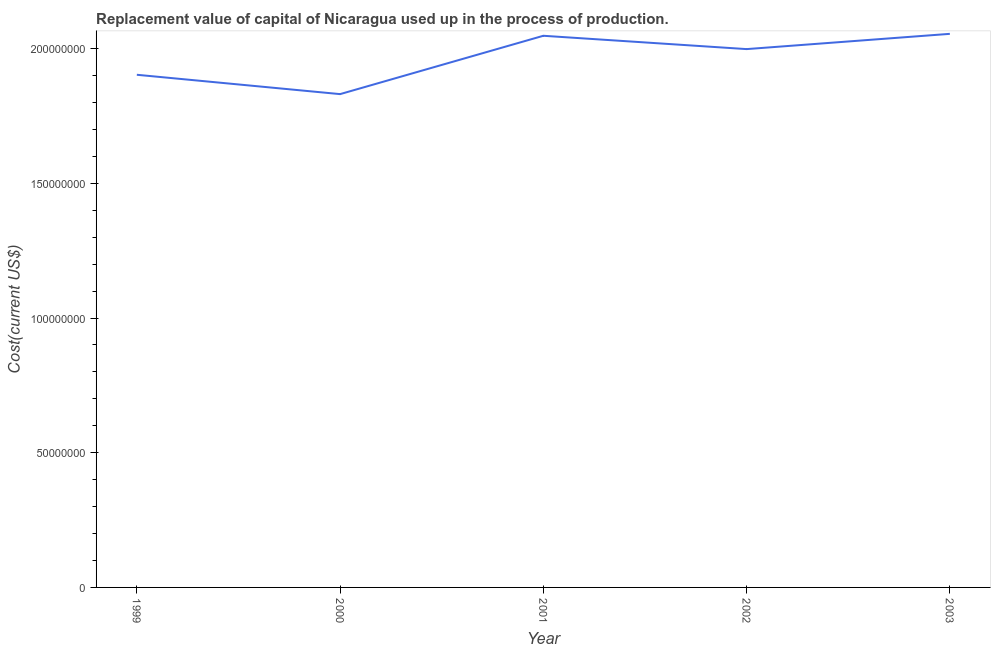What is the consumption of fixed capital in 1999?
Provide a succinct answer. 1.90e+08. Across all years, what is the maximum consumption of fixed capital?
Your answer should be very brief. 2.05e+08. Across all years, what is the minimum consumption of fixed capital?
Keep it short and to the point. 1.83e+08. In which year was the consumption of fixed capital maximum?
Offer a terse response. 2003. In which year was the consumption of fixed capital minimum?
Give a very brief answer. 2000. What is the sum of the consumption of fixed capital?
Provide a succinct answer. 9.83e+08. What is the difference between the consumption of fixed capital in 1999 and 2001?
Keep it short and to the point. -1.45e+07. What is the average consumption of fixed capital per year?
Offer a terse response. 1.97e+08. What is the median consumption of fixed capital?
Keep it short and to the point. 2.00e+08. In how many years, is the consumption of fixed capital greater than 80000000 US$?
Your response must be concise. 5. What is the ratio of the consumption of fixed capital in 1999 to that in 2001?
Ensure brevity in your answer.  0.93. What is the difference between the highest and the second highest consumption of fixed capital?
Offer a terse response. 7.18e+05. Is the sum of the consumption of fixed capital in 1999 and 2002 greater than the maximum consumption of fixed capital across all years?
Your response must be concise. Yes. What is the difference between the highest and the lowest consumption of fixed capital?
Keep it short and to the point. 2.24e+07. In how many years, is the consumption of fixed capital greater than the average consumption of fixed capital taken over all years?
Give a very brief answer. 3. Does the consumption of fixed capital monotonically increase over the years?
Offer a terse response. No. How many lines are there?
Your response must be concise. 1. How many years are there in the graph?
Ensure brevity in your answer.  5. Does the graph contain grids?
Provide a succinct answer. No. What is the title of the graph?
Offer a terse response. Replacement value of capital of Nicaragua used up in the process of production. What is the label or title of the Y-axis?
Provide a short and direct response. Cost(current US$). What is the Cost(current US$) of 1999?
Make the answer very short. 1.90e+08. What is the Cost(current US$) of 2000?
Your response must be concise. 1.83e+08. What is the Cost(current US$) in 2001?
Ensure brevity in your answer.  2.05e+08. What is the Cost(current US$) in 2002?
Ensure brevity in your answer.  2.00e+08. What is the Cost(current US$) of 2003?
Offer a terse response. 2.05e+08. What is the difference between the Cost(current US$) in 1999 and 2000?
Offer a very short reply. 7.18e+06. What is the difference between the Cost(current US$) in 1999 and 2001?
Your answer should be very brief. -1.45e+07. What is the difference between the Cost(current US$) in 1999 and 2002?
Your answer should be very brief. -9.53e+06. What is the difference between the Cost(current US$) in 1999 and 2003?
Provide a succinct answer. -1.52e+07. What is the difference between the Cost(current US$) in 2000 and 2001?
Keep it short and to the point. -2.17e+07. What is the difference between the Cost(current US$) in 2000 and 2002?
Ensure brevity in your answer.  -1.67e+07. What is the difference between the Cost(current US$) in 2000 and 2003?
Offer a very short reply. -2.24e+07. What is the difference between the Cost(current US$) in 2001 and 2002?
Make the answer very short. 4.95e+06. What is the difference between the Cost(current US$) in 2001 and 2003?
Offer a terse response. -7.18e+05. What is the difference between the Cost(current US$) in 2002 and 2003?
Your response must be concise. -5.67e+06. What is the ratio of the Cost(current US$) in 1999 to that in 2000?
Provide a short and direct response. 1.04. What is the ratio of the Cost(current US$) in 1999 to that in 2001?
Provide a short and direct response. 0.93. What is the ratio of the Cost(current US$) in 1999 to that in 2003?
Keep it short and to the point. 0.93. What is the ratio of the Cost(current US$) in 2000 to that in 2001?
Keep it short and to the point. 0.89. What is the ratio of the Cost(current US$) in 2000 to that in 2002?
Your answer should be very brief. 0.92. What is the ratio of the Cost(current US$) in 2000 to that in 2003?
Keep it short and to the point. 0.89. What is the ratio of the Cost(current US$) in 2001 to that in 2002?
Make the answer very short. 1.02. What is the ratio of the Cost(current US$) in 2002 to that in 2003?
Offer a very short reply. 0.97. 